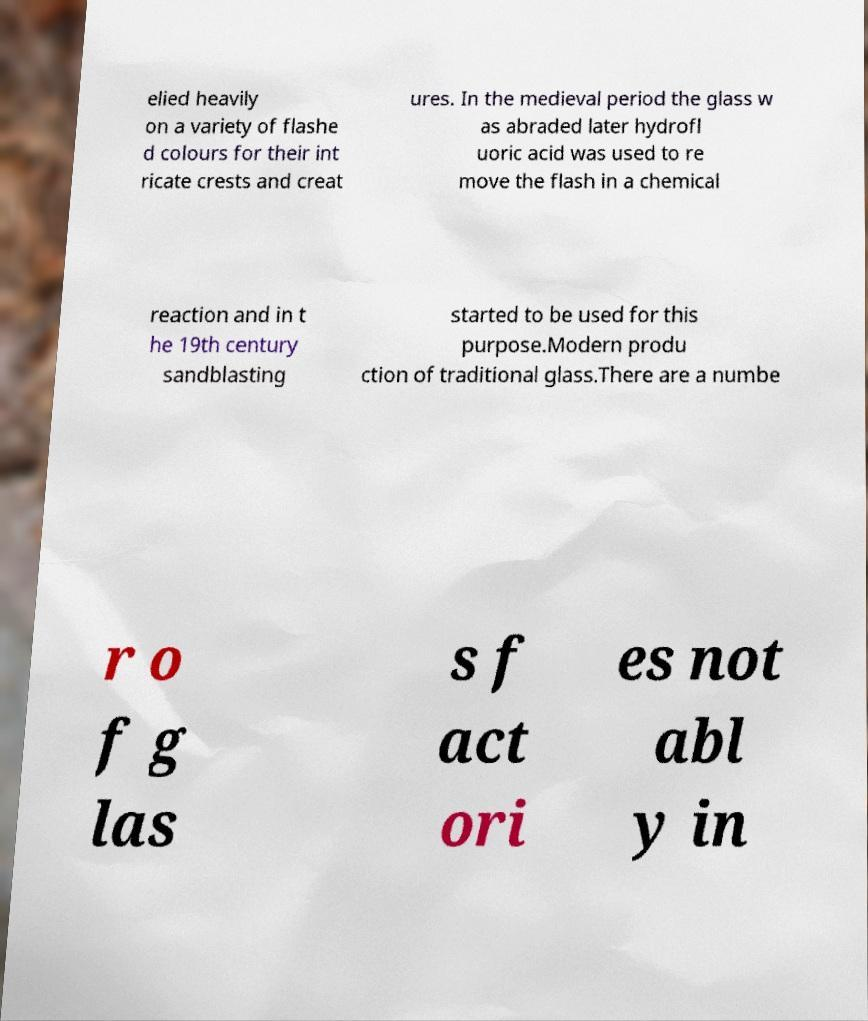Could you assist in decoding the text presented in this image and type it out clearly? elied heavily on a variety of flashe d colours for their int ricate crests and creat ures. In the medieval period the glass w as abraded later hydrofl uoric acid was used to re move the flash in a chemical reaction and in t he 19th century sandblasting started to be used for this purpose.Modern produ ction of traditional glass.There are a numbe r o f g las s f act ori es not abl y in 